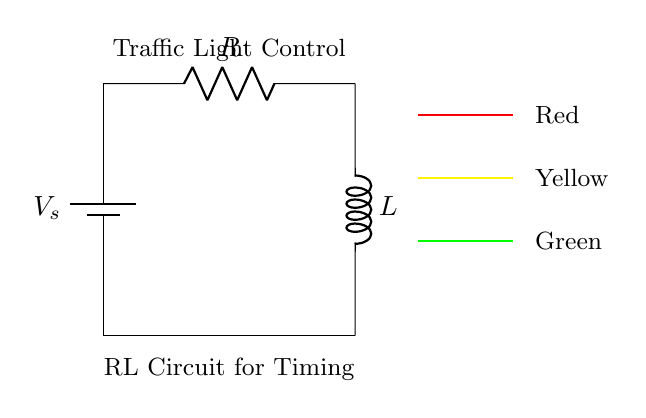What is the power supply voltage in this circuit? The diagram shows a battery labeled V_s, indicating that the voltage source for the circuit is represented by this label. However, the specific voltage value is not provided in the diagram.
Answer: V_s What components are present in the RL circuit? The circuit includes a resistor (labeled R) and an inductor (labeled L). These are the two components that define an RL circuit.
Answer: Resistor, Inductor What is the function of the inductor in this circuit? The inductor is responsible for storing energy in the form of a magnetic field when current passes through it. In a timing control circuit, it influences the timing characteristics of the circuit by controlling the rate of current change.
Answer: Timing control In what order are the traffic light colors displayed? The diagram indicates a sequence of the traffic light colors as red on top, yellow in the middle, and green at the bottom. This order is standard for traffic light systems.
Answer: Red, Yellow, Green How does the resistor affect the circuit? The resistor limits the current flowing through the circuit, which can influence the timing of how quickly the inductor charges or discharges. Thus, it plays a critical role in determining the timing intervals for the traffic light.
Answer: Limits current What role does this RL circuit serve in the traffic light system? The RL circuit is used for timing control, meaning it helps to establish how long each light (red, yellow, green) stays on before changing. The inductor and resistor together create a time delay necessary for safe traffic flow.
Answer: Timing control for traffic lights 